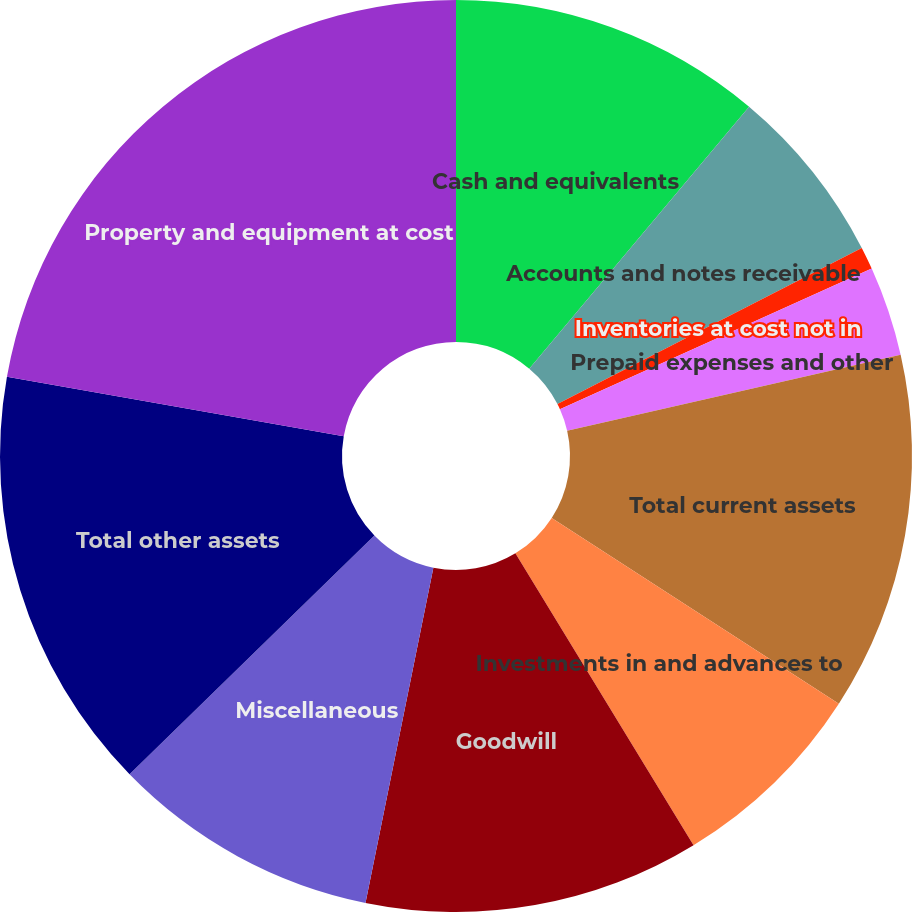Convert chart. <chart><loc_0><loc_0><loc_500><loc_500><pie_chart><fcel>Cash and equivalents<fcel>Accounts and notes receivable<fcel>Inventories at cost not in<fcel>Prepaid expenses and other<fcel>Total current assets<fcel>Investments in and advances to<fcel>Goodwill<fcel>Miscellaneous<fcel>Total other assets<fcel>Property and equipment at cost<nl><fcel>11.11%<fcel>6.35%<fcel>0.8%<fcel>3.18%<fcel>12.7%<fcel>7.14%<fcel>11.9%<fcel>9.52%<fcel>15.08%<fcel>22.22%<nl></chart> 